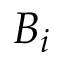Convert formula to latex. <formula><loc_0><loc_0><loc_500><loc_500>B _ { i }</formula> 